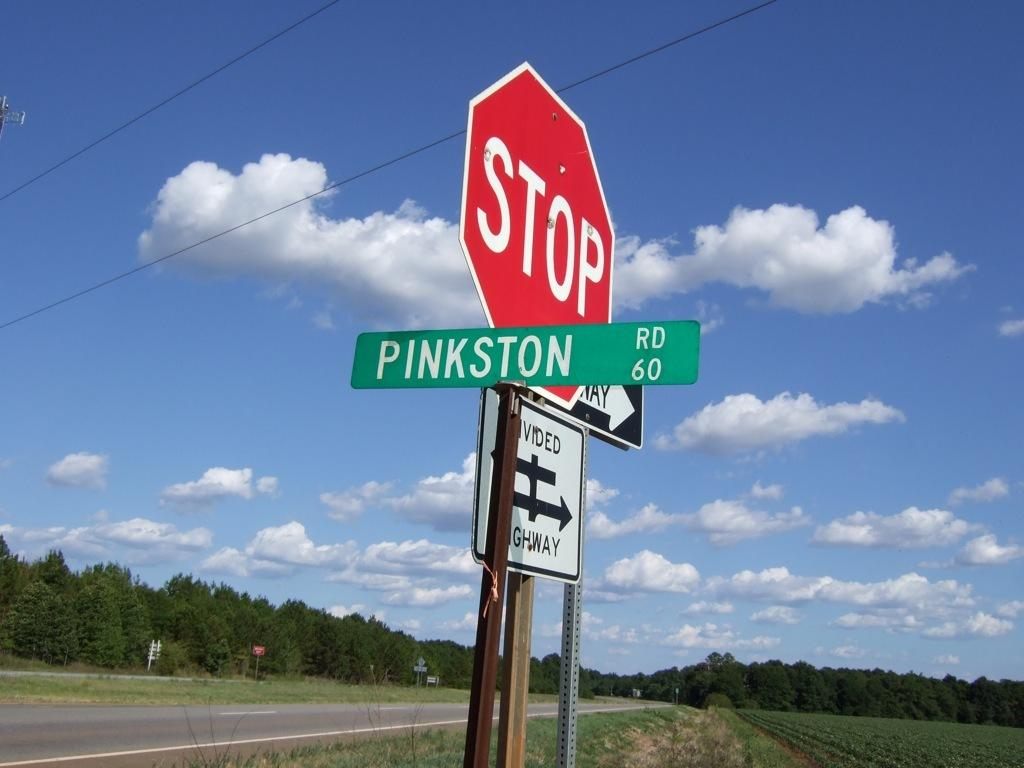<image>
Write a terse but informative summary of the picture. Street signs at an intersection for Pinkston Rd. 